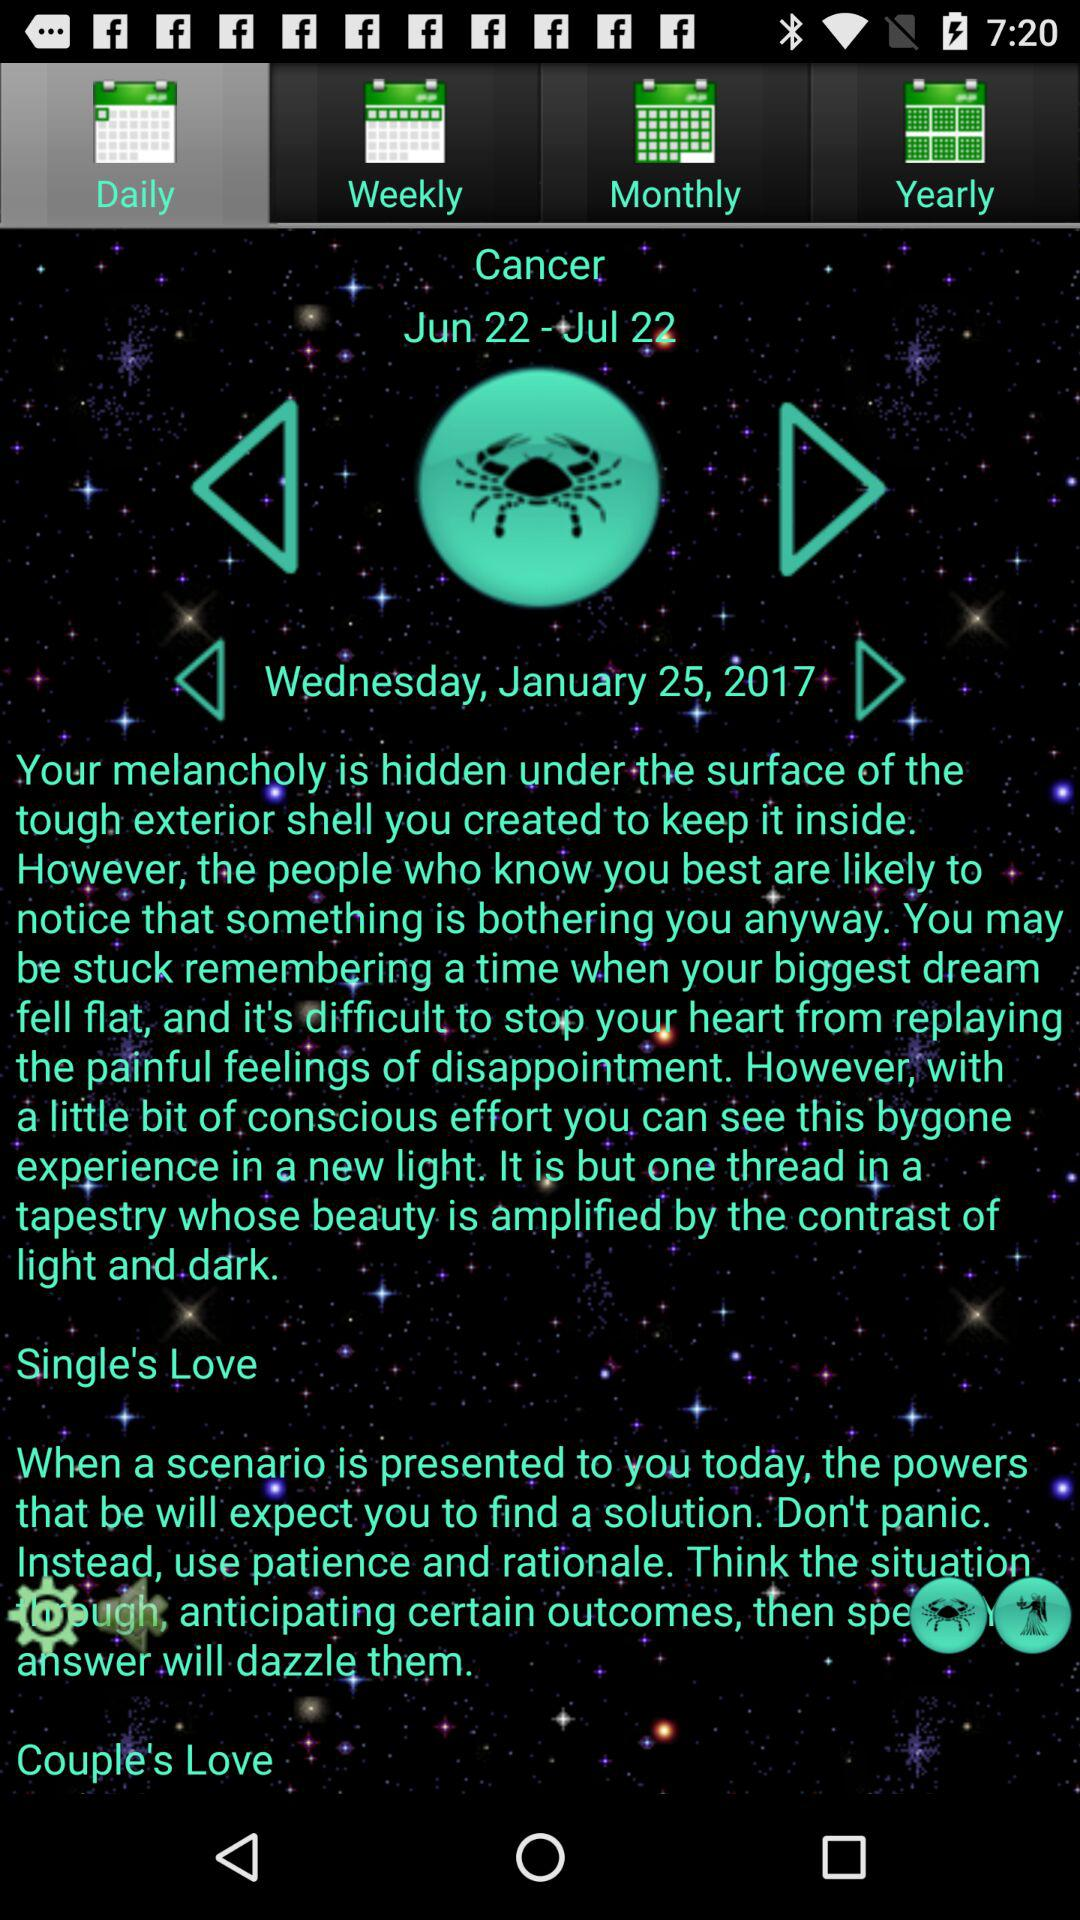Which option is selected? The selected option is "Daily". 